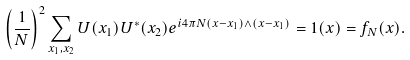<formula> <loc_0><loc_0><loc_500><loc_500>\left ( \frac { 1 } { N } \right ) ^ { 2 } \sum _ { x _ { 1 } , x _ { 2 } } { U } ( x _ { 1 } ) { U } ^ { * } ( x _ { 2 } ) e ^ { i 4 \pi N ( x - x _ { 1 } ) \wedge ( x - x _ { 1 } ) } = { 1 } ( x ) = f _ { N } ( x ) .</formula> 